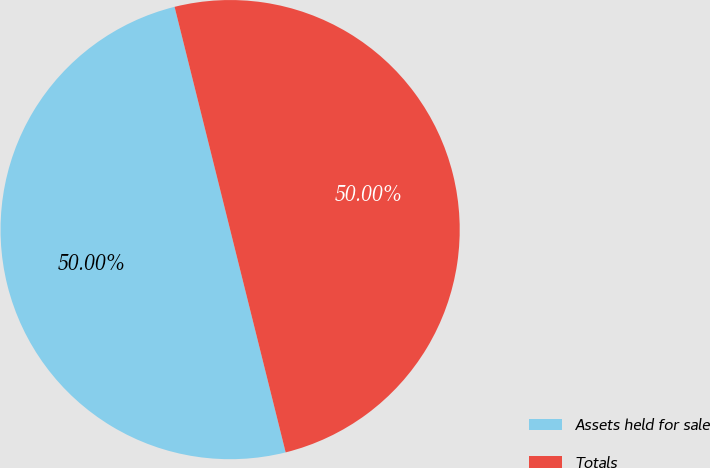<chart> <loc_0><loc_0><loc_500><loc_500><pie_chart><fcel>Assets held for sale<fcel>Totals<nl><fcel>50.0%<fcel>50.0%<nl></chart> 